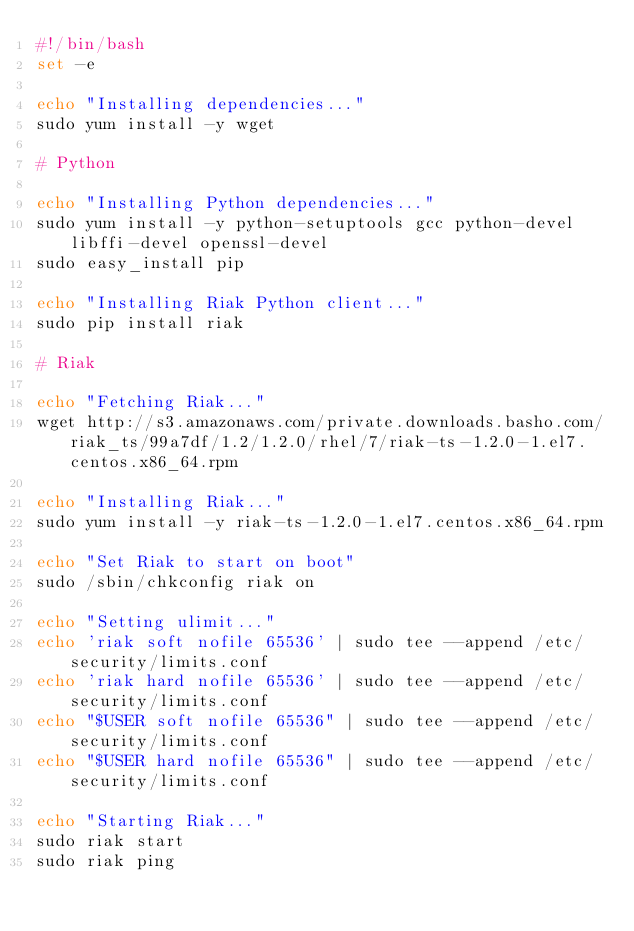<code> <loc_0><loc_0><loc_500><loc_500><_Bash_>#!/bin/bash
set -e

echo "Installing dependencies..."
sudo yum install -y wget

# Python

echo "Installing Python dependencies..."
sudo yum install -y python-setuptools gcc python-devel libffi-devel openssl-devel
sudo easy_install pip

echo "Installing Riak Python client..."
sudo pip install riak

# Riak

echo "Fetching Riak..."
wget http://s3.amazonaws.com/private.downloads.basho.com/riak_ts/99a7df/1.2/1.2.0/rhel/7/riak-ts-1.2.0-1.el7.centos.x86_64.rpm

echo "Installing Riak..."
sudo yum install -y riak-ts-1.2.0-1.el7.centos.x86_64.rpm

echo "Set Riak to start on boot"
sudo /sbin/chkconfig riak on

echo "Setting ulimit..."
echo 'riak soft nofile 65536' | sudo tee --append /etc/security/limits.conf
echo 'riak hard nofile 65536' | sudo tee --append /etc/security/limits.conf
echo "$USER soft nofile 65536" | sudo tee --append /etc/security/limits.conf
echo "$USER hard nofile 65536" | sudo tee --append /etc/security/limits.conf

echo "Starting Riak..."
sudo riak start
sudo riak ping
</code> 